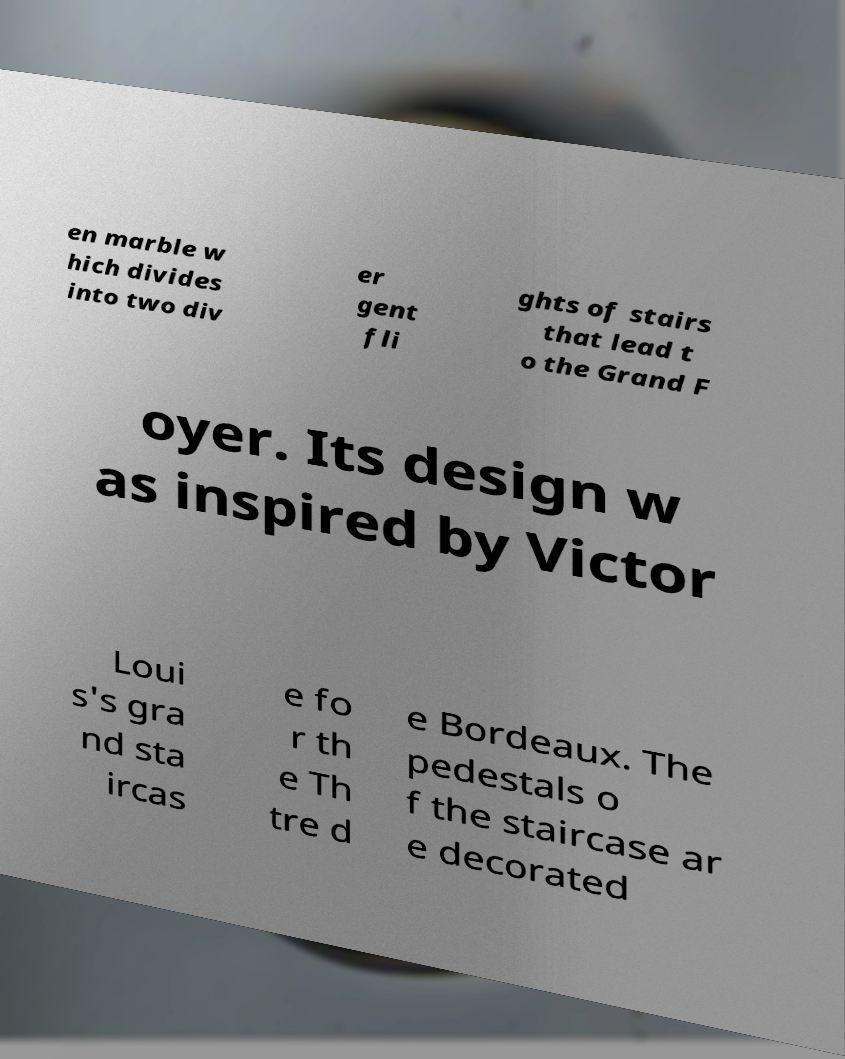For documentation purposes, I need the text within this image transcribed. Could you provide that? en marble w hich divides into two div er gent fli ghts of stairs that lead t o the Grand F oyer. Its design w as inspired by Victor Loui s's gra nd sta ircas e fo r th e Th tre d e Bordeaux. The pedestals o f the staircase ar e decorated 